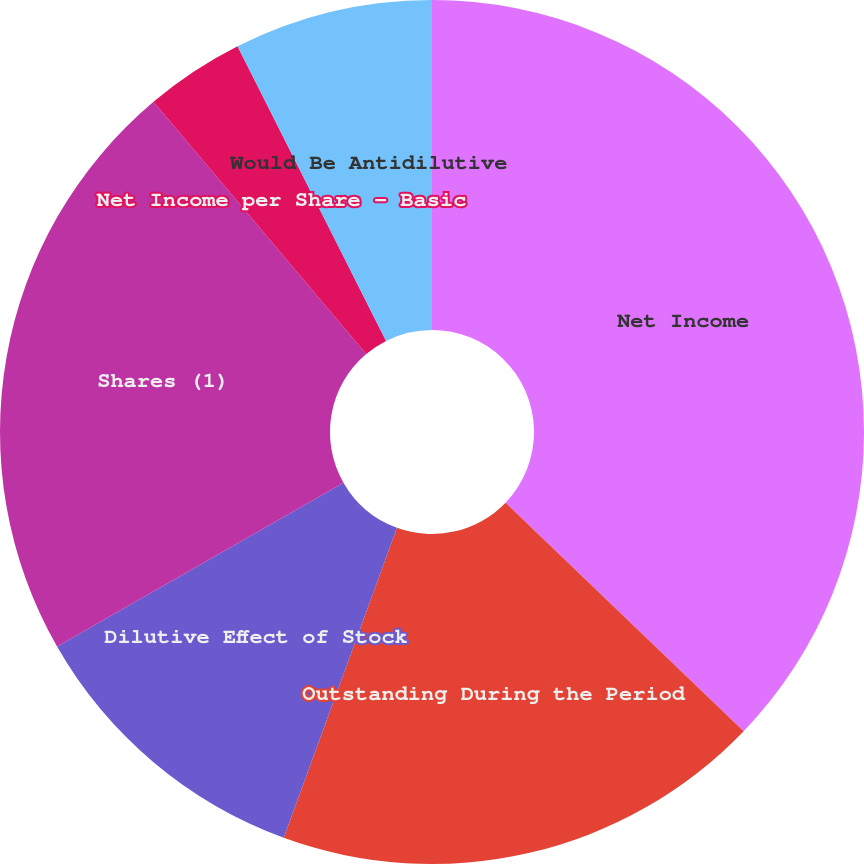Convert chart to OTSL. <chart><loc_0><loc_0><loc_500><loc_500><pie_chart><fcel>Net Income<fcel>Outstanding During the Period<fcel>Dilutive Effect of Stock<fcel>Shares (1)<fcel>Net Income per Share - Basic<fcel>Net Income per Share - Diluted<fcel>Would Be Antidilutive<nl><fcel>37.17%<fcel>18.4%<fcel>11.15%<fcel>22.12%<fcel>3.72%<fcel>0.0%<fcel>7.43%<nl></chart> 